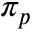<formula> <loc_0><loc_0><loc_500><loc_500>\pi _ { p }</formula> 